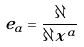Convert formula to latex. <formula><loc_0><loc_0><loc_500><loc_500>e _ { a } = \frac { \partial } { \partial x ^ { a } }</formula> 